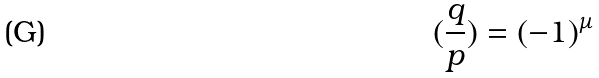<formula> <loc_0><loc_0><loc_500><loc_500>( \frac { q } { p } ) = ( - 1 ) ^ { \mu }</formula> 